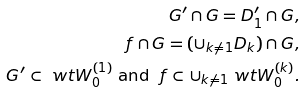Convert formula to latex. <formula><loc_0><loc_0><loc_500><loc_500>G ^ { \prime } \cap G = D _ { 1 } ^ { \prime } \cap G , \\ \ f \cap G = ( \cup _ { k \ne 1 } D _ { k } ) \cap G , \\ G ^ { \prime } \subset \ w t { W } _ { 0 } ^ { ( 1 ) } \text { and } \ f \subset \cup _ { k \ne 1 } \ w t { W } _ { 0 } ^ { ( k ) } .</formula> 